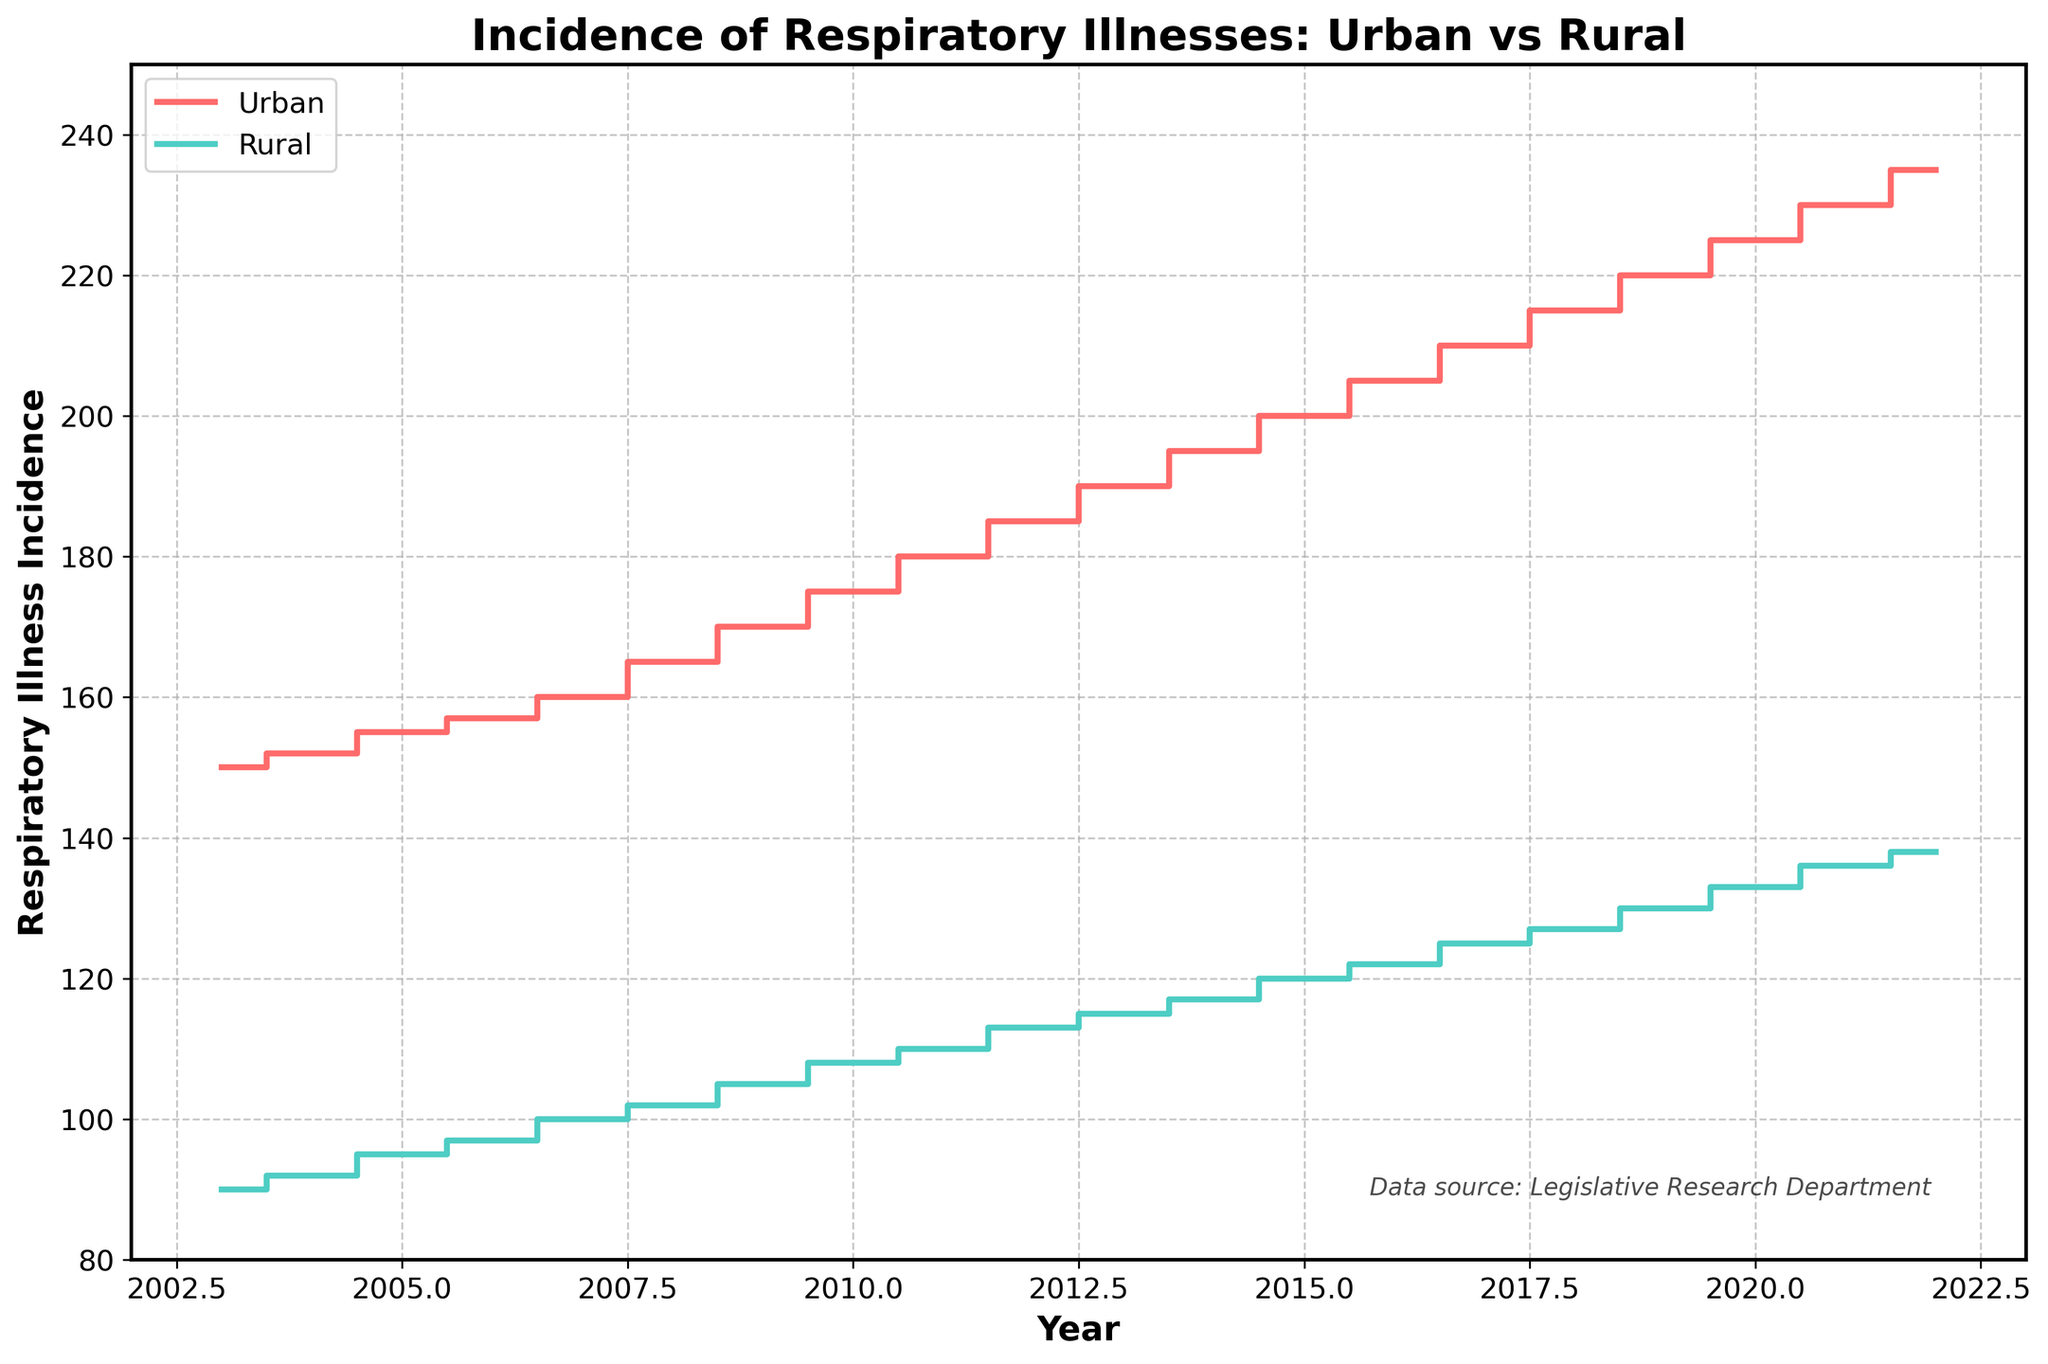What is the title of the figure? The title of the figure is located at the top. It provides the main topic of the visual representation.
Answer: Incidence of Respiratory Illnesses: Urban vs Rural How does the trend of respiratory illness incidence in urban areas compare to rural areas? To compare trends, look at the overall direction in both lines. Both lines are increasing, indicating rising cases in both urban and rural areas over 20 years.
Answer: Both are increasing What is the incidence of respiratory illnesses in urban areas in 2010? Find the year 2010 on the x-axis and look at the urban (red) line's position.
Answer: 175 In which year is the difference between urban and rural respiratory illness incidence the greatest? Calculate the difference between urban and rural values for each year and find the maximum difference. In 2022, the difference is largest (235 - 138 = 97).
Answer: 2022 What is the average increase in respiratory illness incidence per year for rural areas? Find the difference in rural incidence between 2022 and 2003 (138 - 90 = 48) and divide by the number of years (2022 - 2003 = 19 years).
Answer: About 2.52 How many times is the incidence of respiratory illnesses in urban areas greater than in rural areas in 2022? Divide urban incidence by rural incidence for the year 2022 (235 / 138).
Answer: About 1.70 times What is the difference in respiratory illness incidence between urban and rural areas in 2007? Look at the values for 2007 and subtract rural from urban (160 - 100).
Answer: 60 During which years does the incidence of respiratory illnesses in rural areas exceed 120? Observe the rural (turquoise) line and note the years when the value crosses above 120 (2015 onwards).
Answer: 2015 - 2022 Between which two consecutive years did the urban incidence of respiratory illnesses experience the highest increase? Calculate the yearly differences and identify the maximum increase. The largest jump is from 2008 to 2009 (170 - 165 = 5).
Answer: 2008-2009 How does the variation in incidence over the years compare between urban and rural areas? Compare the range or differences between the maximum and minimum values over the period for each series. Urban varies from 150 to 235, while rural varies from 90 to 138.
Answer: Urban has greater variation 